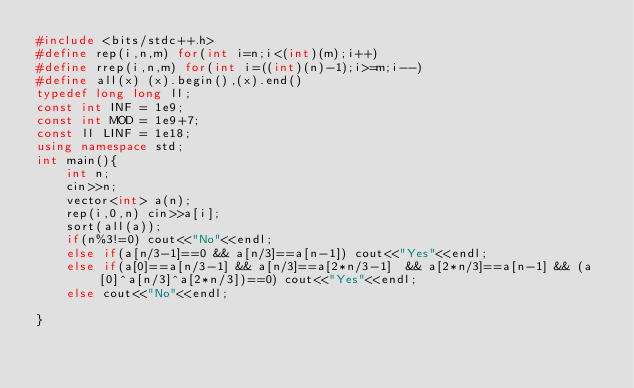Convert code to text. <code><loc_0><loc_0><loc_500><loc_500><_C++_>#include <bits/stdc++.h>
#define rep(i,n,m) for(int i=n;i<(int)(m);i++)
#define rrep(i,n,m) for(int i=((int)(n)-1);i>=m;i--)
#define all(x) (x).begin(),(x).end()
typedef long long ll;
const int INF = 1e9;
const int MOD = 1e9+7;
const ll LINF = 1e18;
using namespace std;
int main(){
    int n;
    cin>>n;
    vector<int> a(n);
    rep(i,0,n) cin>>a[i];
    sort(all(a));
    if(n%3!=0) cout<<"No"<<endl;
    else if(a[n/3-1]==0 && a[n/3]==a[n-1]) cout<<"Yes"<<endl;
    else if(a[0]==a[n/3-1] && a[n/3]==a[2*n/3-1]  && a[2*n/3]==a[n-1] && (a[0]^a[n/3]^a[2*n/3])==0) cout<<"Yes"<<endl;
    else cout<<"No"<<endl;
    
}

</code> 